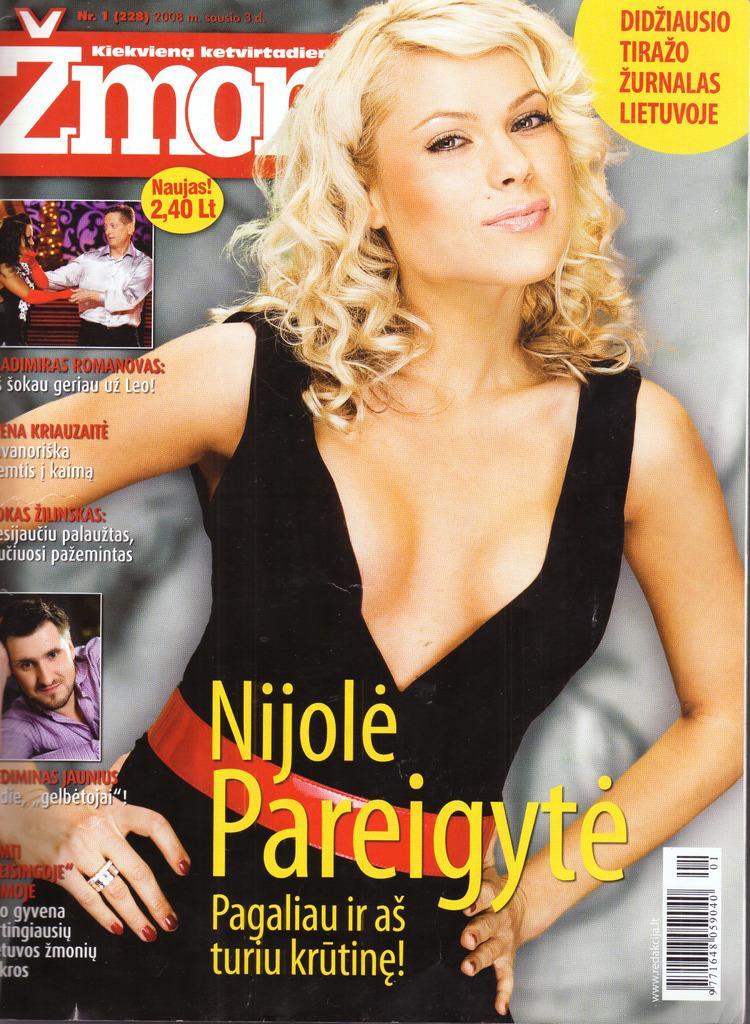In one or two sentences, can you explain what this image depicts? In this picture it looks like a poster, in the middle there is a woman, at the bottom there is the text, on the left side there are men. 